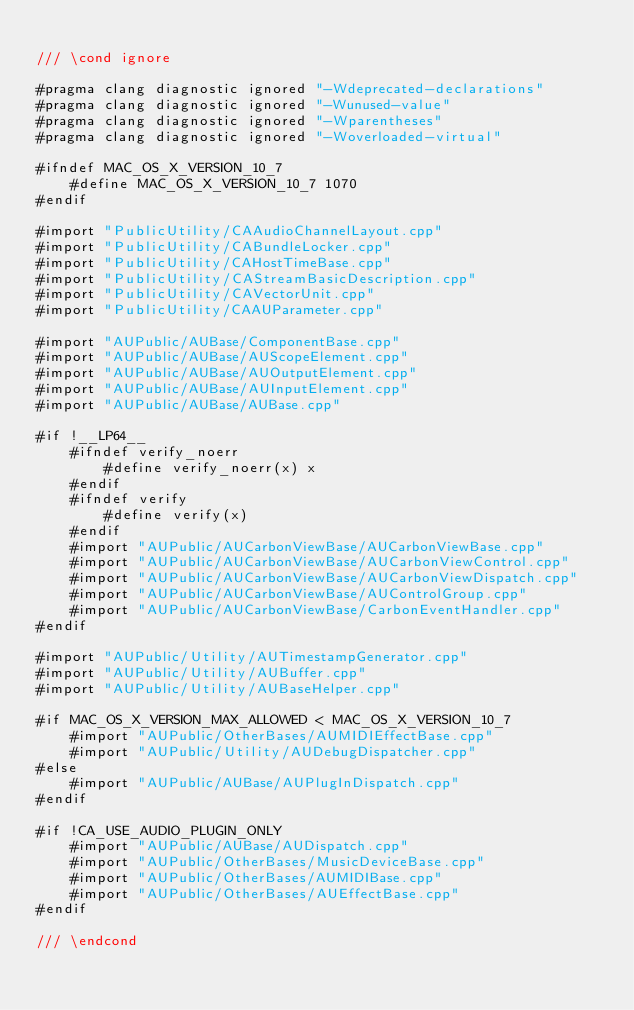<code> <loc_0><loc_0><loc_500><loc_500><_ObjectiveC_>
/// \cond ignore

#pragma clang diagnostic ignored "-Wdeprecated-declarations"
#pragma clang diagnostic ignored "-Wunused-value"
#pragma clang diagnostic ignored "-Wparentheses"
#pragma clang diagnostic ignored "-Woverloaded-virtual"

#ifndef MAC_OS_X_VERSION_10_7
	#define MAC_OS_X_VERSION_10_7 1070
#endif

#import "PublicUtility/CAAudioChannelLayout.cpp"
#import "PublicUtility/CABundleLocker.cpp"
#import "PublicUtility/CAHostTimeBase.cpp"
#import "PublicUtility/CAStreamBasicDescription.cpp"
#import "PublicUtility/CAVectorUnit.cpp"
#import "PublicUtility/CAAUParameter.cpp"

#import "AUPublic/AUBase/ComponentBase.cpp"
#import "AUPublic/AUBase/AUScopeElement.cpp"
#import "AUPublic/AUBase/AUOutputElement.cpp"
#import "AUPublic/AUBase/AUInputElement.cpp"
#import "AUPublic/AUBase/AUBase.cpp"

#if !__LP64__
	#ifndef verify_noerr
		#define verify_noerr(x) x
	#endif
	#ifndef verify
		#define verify(x)
	#endif
	#import "AUPublic/AUCarbonViewBase/AUCarbonViewBase.cpp"
	#import "AUPublic/AUCarbonViewBase/AUCarbonViewControl.cpp"
	#import "AUPublic/AUCarbonViewBase/AUCarbonViewDispatch.cpp"
	#import "AUPublic/AUCarbonViewBase/AUControlGroup.cpp"
	#import "AUPublic/AUCarbonViewBase/CarbonEventHandler.cpp"
#endif

#import "AUPublic/Utility/AUTimestampGenerator.cpp"
#import "AUPublic/Utility/AUBuffer.cpp"
#import "AUPublic/Utility/AUBaseHelper.cpp"

#if MAC_OS_X_VERSION_MAX_ALLOWED < MAC_OS_X_VERSION_10_7
	#import "AUPublic/OtherBases/AUMIDIEffectBase.cpp"
	#import "AUPublic/Utility/AUDebugDispatcher.cpp"
#else
	#import "AUPublic/AUBase/AUPlugInDispatch.cpp"
#endif

#if !CA_USE_AUDIO_PLUGIN_ONLY
	#import "AUPublic/AUBase/AUDispatch.cpp"
	#import "AUPublic/OtherBases/MusicDeviceBase.cpp"
	#import "AUPublic/OtherBases/AUMIDIBase.cpp"
	#import "AUPublic/OtherBases/AUEffectBase.cpp"
#endif

/// \endcond
</code> 